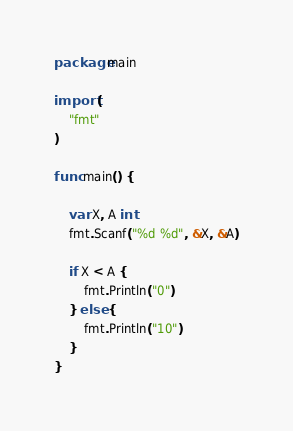<code> <loc_0><loc_0><loc_500><loc_500><_Go_>package main

import (
	"fmt"
)

func main() {

	var X, A int
	fmt.Scanf("%d %d", &X, &A)

	if X < A {
		fmt.Println("0")
	} else {
		fmt.Println("10")
	}
}
</code> 